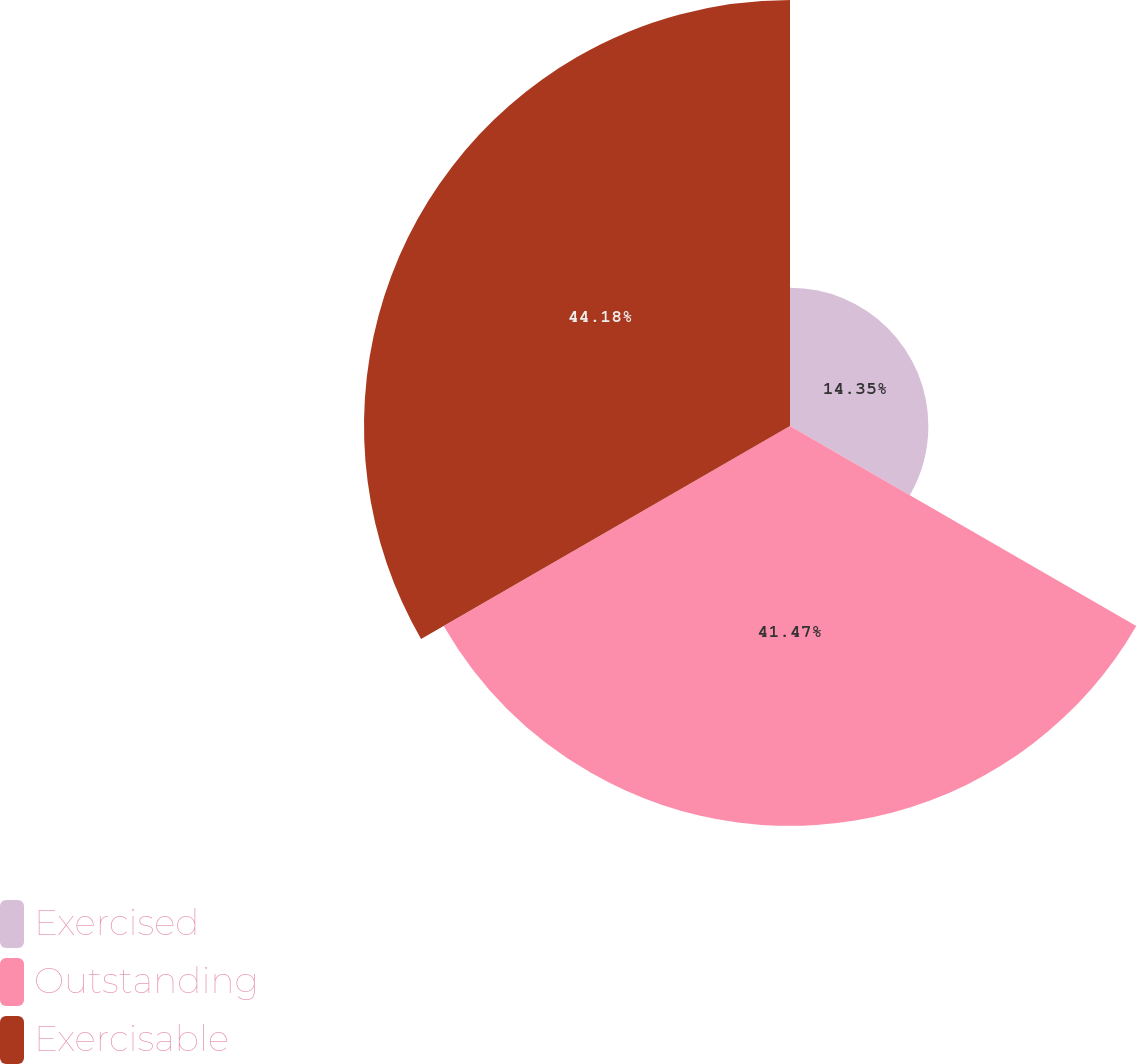Convert chart to OTSL. <chart><loc_0><loc_0><loc_500><loc_500><pie_chart><fcel>Exercised<fcel>Outstanding<fcel>Exercisable<nl><fcel>14.35%<fcel>41.47%<fcel>44.18%<nl></chart> 